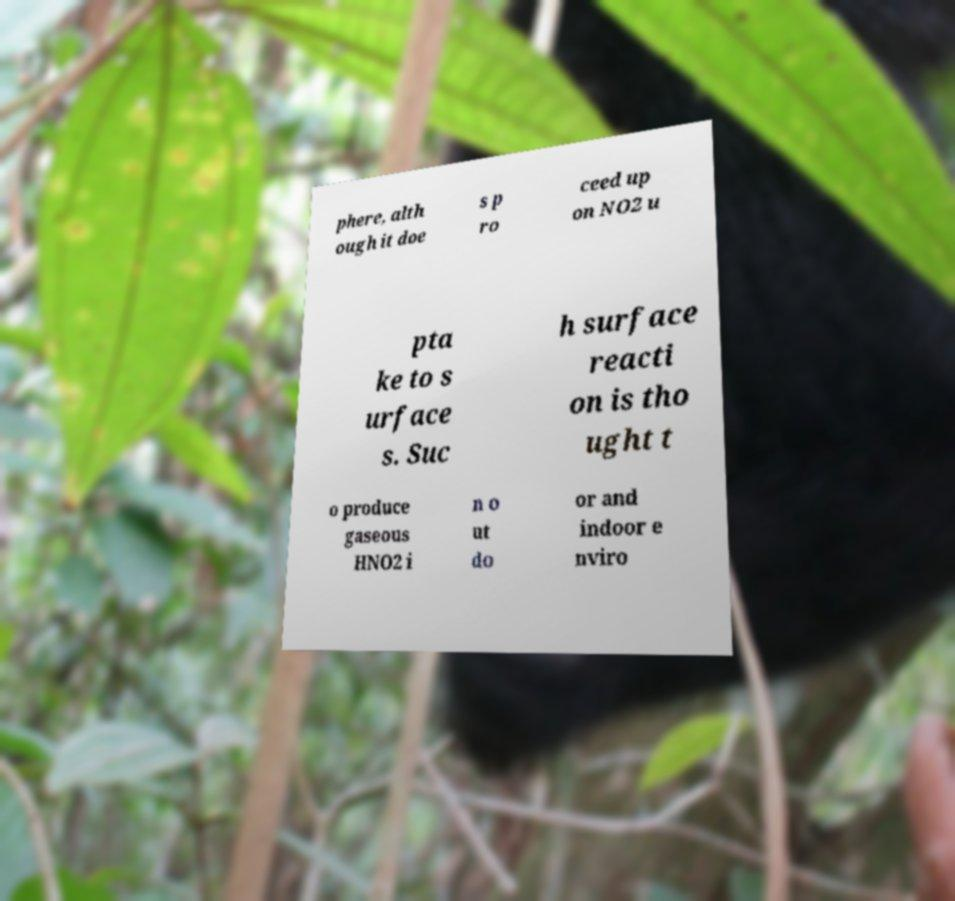Could you assist in decoding the text presented in this image and type it out clearly? phere, alth ough it doe s p ro ceed up on NO2 u pta ke to s urface s. Suc h surface reacti on is tho ught t o produce gaseous HNO2 i n o ut do or and indoor e nviro 